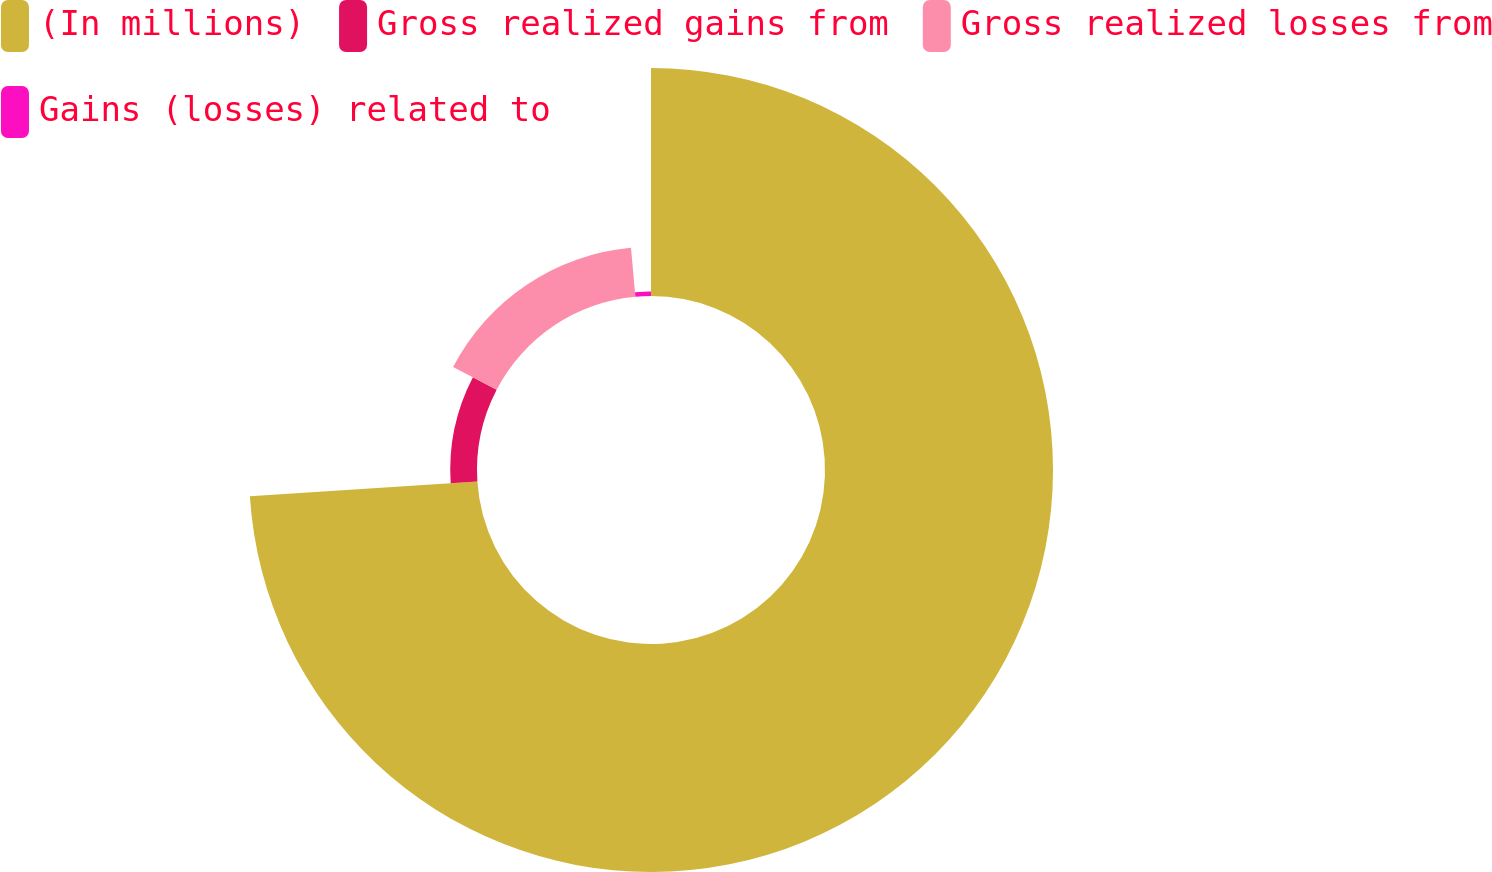Convert chart. <chart><loc_0><loc_0><loc_500><loc_500><pie_chart><fcel>(In millions)<fcel>Gross realized gains from<fcel>Gross realized losses from<fcel>Gains (losses) related to<nl><fcel>73.95%<fcel>8.68%<fcel>15.93%<fcel>1.43%<nl></chart> 